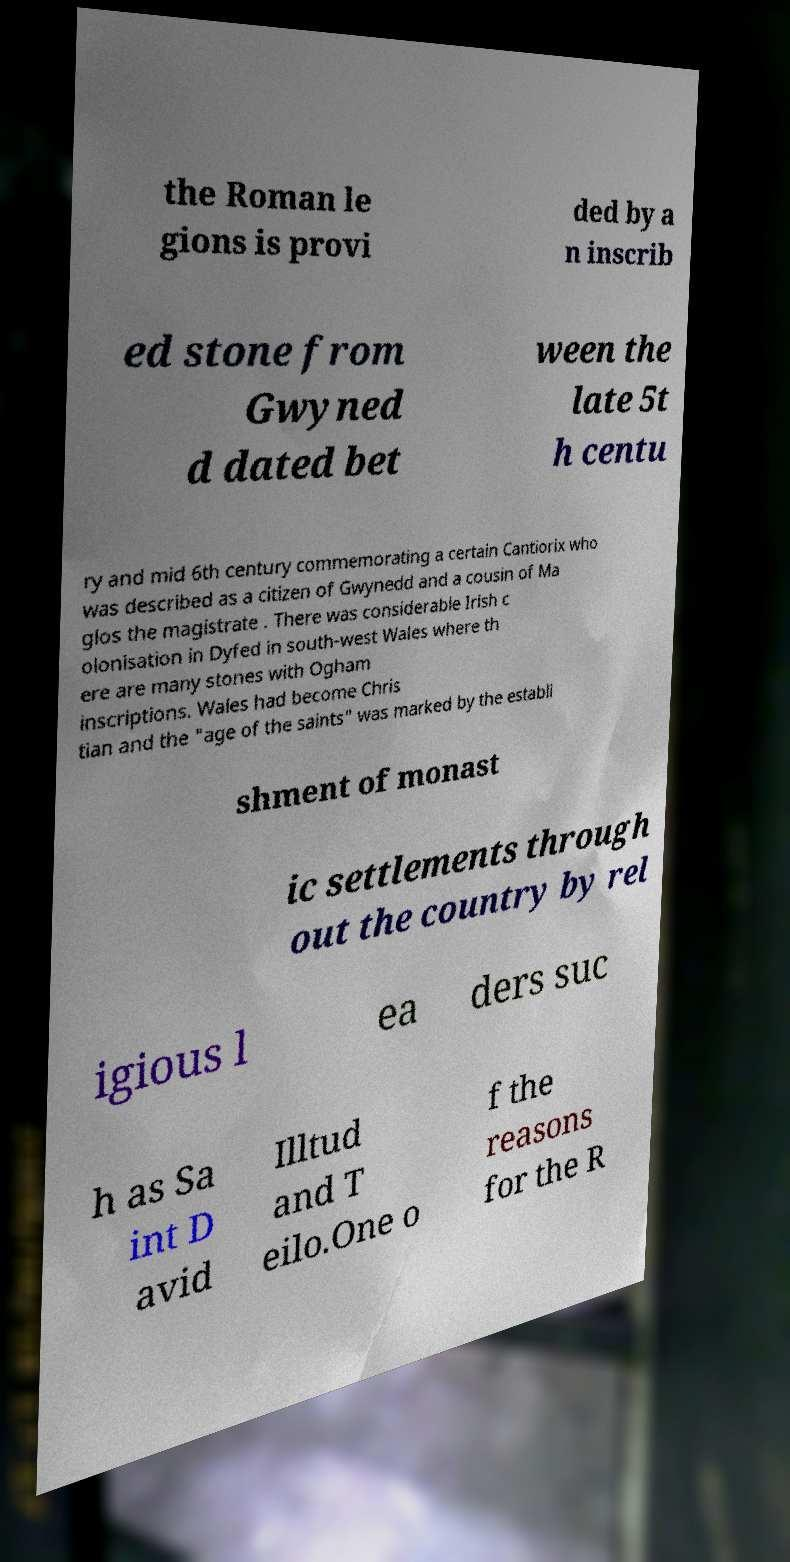Could you extract and type out the text from this image? the Roman le gions is provi ded by a n inscrib ed stone from Gwyned d dated bet ween the late 5t h centu ry and mid 6th century commemorating a certain Cantiorix who was described as a citizen of Gwynedd and a cousin of Ma glos the magistrate . There was considerable Irish c olonisation in Dyfed in south-west Wales where th ere are many stones with Ogham inscriptions. Wales had become Chris tian and the "age of the saints" was marked by the establi shment of monast ic settlements through out the country by rel igious l ea ders suc h as Sa int D avid Illtud and T eilo.One o f the reasons for the R 